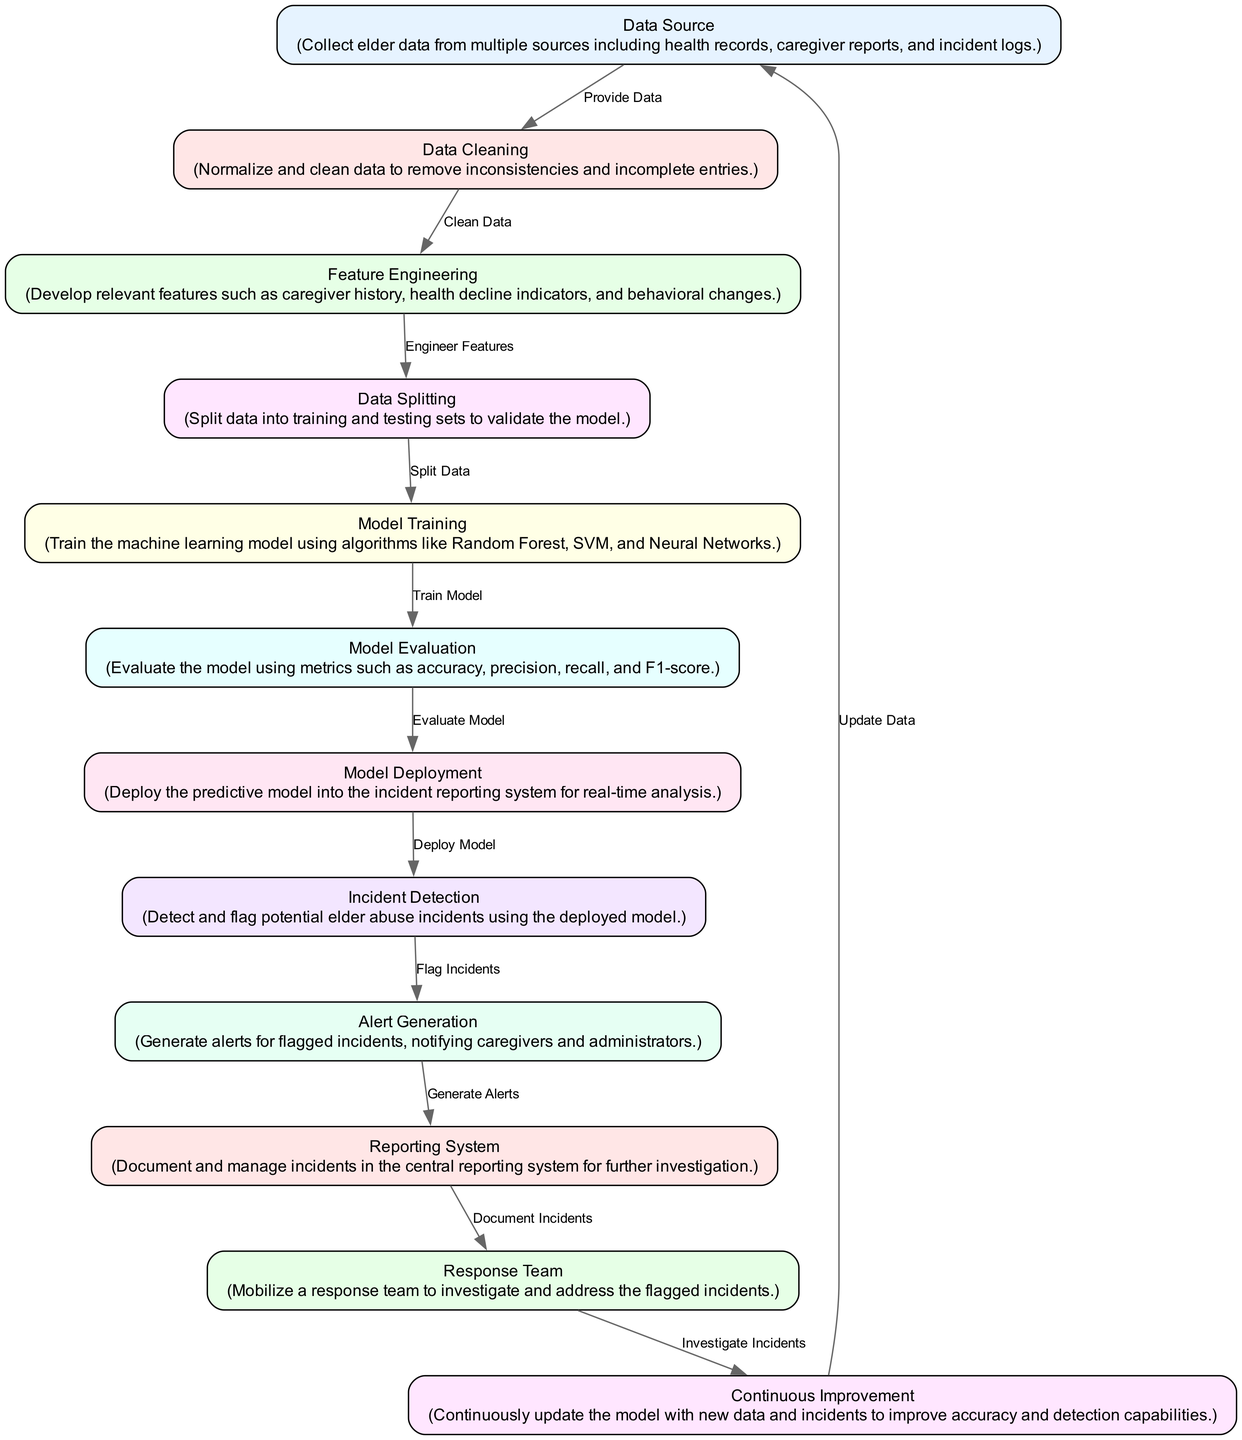What is the first step in the elder abuse detection model? The first step is "Data Source," which involves collecting elder data from various sources.
Answer: Data Source How many nodes are in this diagram? There are 12 nodes represented in the diagram.
Answer: 12 Which node comes after "Data Cleaning"? The node that comes after "Data Cleaning" is "Feature Engineering," which handles the development of relevant features.
Answer: Feature Engineering What metric is used for model evaluation? The model evaluation uses several metrics including accuracy, precision, recall, and F1-score.
Answer: accuracy, precision, recall, F1-score What happens after "Incident Detection"? After "Incident Detection," the diagram indicates "Alert Generation," where alerts are generated for flagged incidents.
Answer: Alert Generation What is the primary purpose of the "Response Team" node? The primary purpose of the "Response Team" node is to investigate and address the flagged incidents reported by the system.
Answer: Investigate and address incidents Which step follows the "Model Training"? The step that follows "Model Training" is "Model Evaluation," where the model's performance is assessed.
Answer: Model Evaluation How does "Continuous Improvement" relate to "Data Source"? "Continuous Improvement" updates the model with new data and incidents, which subsequently feeds back into "Data Source" for further enhancement.
Answer: Update Data What kind of actions does "Alert Generation" initiate? "Alert Generation" initiates actions to notify caregivers and administrators about flagged incidents of potential elder abuse.
Answer: Notify caregivers and administrators 